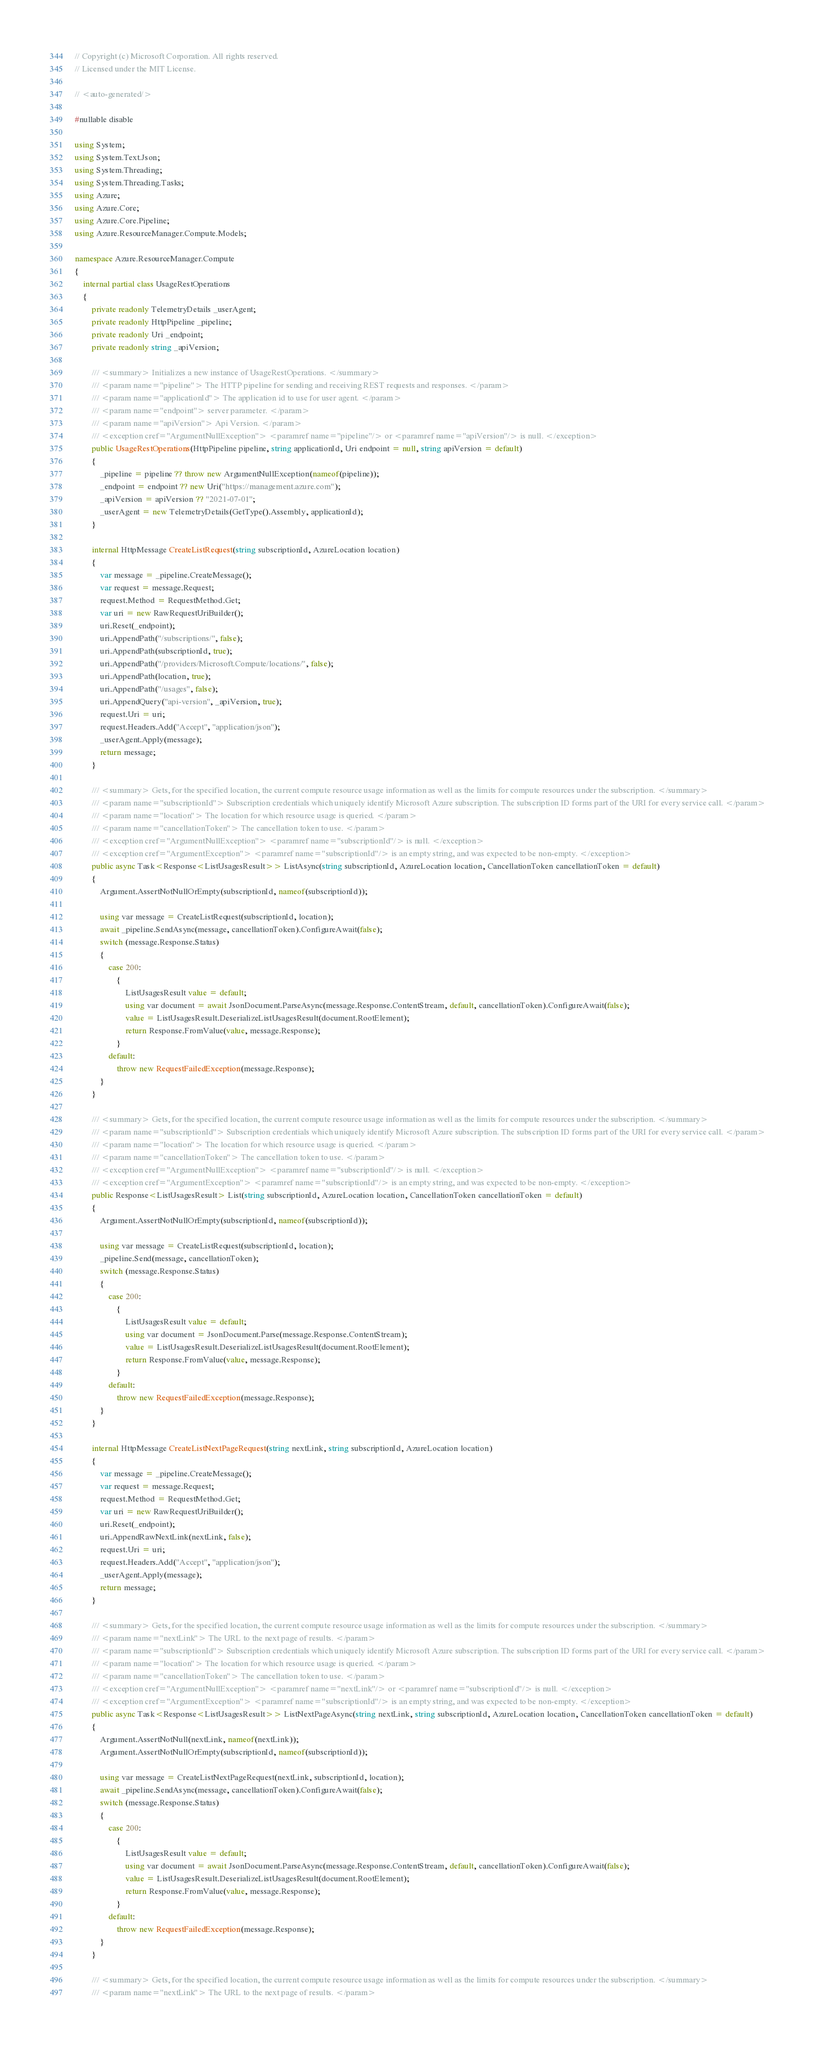Convert code to text. <code><loc_0><loc_0><loc_500><loc_500><_C#_>// Copyright (c) Microsoft Corporation. All rights reserved.
// Licensed under the MIT License.

// <auto-generated/>

#nullable disable

using System;
using System.Text.Json;
using System.Threading;
using System.Threading.Tasks;
using Azure;
using Azure.Core;
using Azure.Core.Pipeline;
using Azure.ResourceManager.Compute.Models;

namespace Azure.ResourceManager.Compute
{
    internal partial class UsageRestOperations
    {
        private readonly TelemetryDetails _userAgent;
        private readonly HttpPipeline _pipeline;
        private readonly Uri _endpoint;
        private readonly string _apiVersion;

        /// <summary> Initializes a new instance of UsageRestOperations. </summary>
        /// <param name="pipeline"> The HTTP pipeline for sending and receiving REST requests and responses. </param>
        /// <param name="applicationId"> The application id to use for user agent. </param>
        /// <param name="endpoint"> server parameter. </param>
        /// <param name="apiVersion"> Api Version. </param>
        /// <exception cref="ArgumentNullException"> <paramref name="pipeline"/> or <paramref name="apiVersion"/> is null. </exception>
        public UsageRestOperations(HttpPipeline pipeline, string applicationId, Uri endpoint = null, string apiVersion = default)
        {
            _pipeline = pipeline ?? throw new ArgumentNullException(nameof(pipeline));
            _endpoint = endpoint ?? new Uri("https://management.azure.com");
            _apiVersion = apiVersion ?? "2021-07-01";
            _userAgent = new TelemetryDetails(GetType().Assembly, applicationId);
        }

        internal HttpMessage CreateListRequest(string subscriptionId, AzureLocation location)
        {
            var message = _pipeline.CreateMessage();
            var request = message.Request;
            request.Method = RequestMethod.Get;
            var uri = new RawRequestUriBuilder();
            uri.Reset(_endpoint);
            uri.AppendPath("/subscriptions/", false);
            uri.AppendPath(subscriptionId, true);
            uri.AppendPath("/providers/Microsoft.Compute/locations/", false);
            uri.AppendPath(location, true);
            uri.AppendPath("/usages", false);
            uri.AppendQuery("api-version", _apiVersion, true);
            request.Uri = uri;
            request.Headers.Add("Accept", "application/json");
            _userAgent.Apply(message);
            return message;
        }

        /// <summary> Gets, for the specified location, the current compute resource usage information as well as the limits for compute resources under the subscription. </summary>
        /// <param name="subscriptionId"> Subscription credentials which uniquely identify Microsoft Azure subscription. The subscription ID forms part of the URI for every service call. </param>
        /// <param name="location"> The location for which resource usage is queried. </param>
        /// <param name="cancellationToken"> The cancellation token to use. </param>
        /// <exception cref="ArgumentNullException"> <paramref name="subscriptionId"/> is null. </exception>
        /// <exception cref="ArgumentException"> <paramref name="subscriptionId"/> is an empty string, and was expected to be non-empty. </exception>
        public async Task<Response<ListUsagesResult>> ListAsync(string subscriptionId, AzureLocation location, CancellationToken cancellationToken = default)
        {
            Argument.AssertNotNullOrEmpty(subscriptionId, nameof(subscriptionId));

            using var message = CreateListRequest(subscriptionId, location);
            await _pipeline.SendAsync(message, cancellationToken).ConfigureAwait(false);
            switch (message.Response.Status)
            {
                case 200:
                    {
                        ListUsagesResult value = default;
                        using var document = await JsonDocument.ParseAsync(message.Response.ContentStream, default, cancellationToken).ConfigureAwait(false);
                        value = ListUsagesResult.DeserializeListUsagesResult(document.RootElement);
                        return Response.FromValue(value, message.Response);
                    }
                default:
                    throw new RequestFailedException(message.Response);
            }
        }

        /// <summary> Gets, for the specified location, the current compute resource usage information as well as the limits for compute resources under the subscription. </summary>
        /// <param name="subscriptionId"> Subscription credentials which uniquely identify Microsoft Azure subscription. The subscription ID forms part of the URI for every service call. </param>
        /// <param name="location"> The location for which resource usage is queried. </param>
        /// <param name="cancellationToken"> The cancellation token to use. </param>
        /// <exception cref="ArgumentNullException"> <paramref name="subscriptionId"/> is null. </exception>
        /// <exception cref="ArgumentException"> <paramref name="subscriptionId"/> is an empty string, and was expected to be non-empty. </exception>
        public Response<ListUsagesResult> List(string subscriptionId, AzureLocation location, CancellationToken cancellationToken = default)
        {
            Argument.AssertNotNullOrEmpty(subscriptionId, nameof(subscriptionId));

            using var message = CreateListRequest(subscriptionId, location);
            _pipeline.Send(message, cancellationToken);
            switch (message.Response.Status)
            {
                case 200:
                    {
                        ListUsagesResult value = default;
                        using var document = JsonDocument.Parse(message.Response.ContentStream);
                        value = ListUsagesResult.DeserializeListUsagesResult(document.RootElement);
                        return Response.FromValue(value, message.Response);
                    }
                default:
                    throw new RequestFailedException(message.Response);
            }
        }

        internal HttpMessage CreateListNextPageRequest(string nextLink, string subscriptionId, AzureLocation location)
        {
            var message = _pipeline.CreateMessage();
            var request = message.Request;
            request.Method = RequestMethod.Get;
            var uri = new RawRequestUriBuilder();
            uri.Reset(_endpoint);
            uri.AppendRawNextLink(nextLink, false);
            request.Uri = uri;
            request.Headers.Add("Accept", "application/json");
            _userAgent.Apply(message);
            return message;
        }

        /// <summary> Gets, for the specified location, the current compute resource usage information as well as the limits for compute resources under the subscription. </summary>
        /// <param name="nextLink"> The URL to the next page of results. </param>
        /// <param name="subscriptionId"> Subscription credentials which uniquely identify Microsoft Azure subscription. The subscription ID forms part of the URI for every service call. </param>
        /// <param name="location"> The location for which resource usage is queried. </param>
        /// <param name="cancellationToken"> The cancellation token to use. </param>
        /// <exception cref="ArgumentNullException"> <paramref name="nextLink"/> or <paramref name="subscriptionId"/> is null. </exception>
        /// <exception cref="ArgumentException"> <paramref name="subscriptionId"/> is an empty string, and was expected to be non-empty. </exception>
        public async Task<Response<ListUsagesResult>> ListNextPageAsync(string nextLink, string subscriptionId, AzureLocation location, CancellationToken cancellationToken = default)
        {
            Argument.AssertNotNull(nextLink, nameof(nextLink));
            Argument.AssertNotNullOrEmpty(subscriptionId, nameof(subscriptionId));

            using var message = CreateListNextPageRequest(nextLink, subscriptionId, location);
            await _pipeline.SendAsync(message, cancellationToken).ConfigureAwait(false);
            switch (message.Response.Status)
            {
                case 200:
                    {
                        ListUsagesResult value = default;
                        using var document = await JsonDocument.ParseAsync(message.Response.ContentStream, default, cancellationToken).ConfigureAwait(false);
                        value = ListUsagesResult.DeserializeListUsagesResult(document.RootElement);
                        return Response.FromValue(value, message.Response);
                    }
                default:
                    throw new RequestFailedException(message.Response);
            }
        }

        /// <summary> Gets, for the specified location, the current compute resource usage information as well as the limits for compute resources under the subscription. </summary>
        /// <param name="nextLink"> The URL to the next page of results. </param></code> 